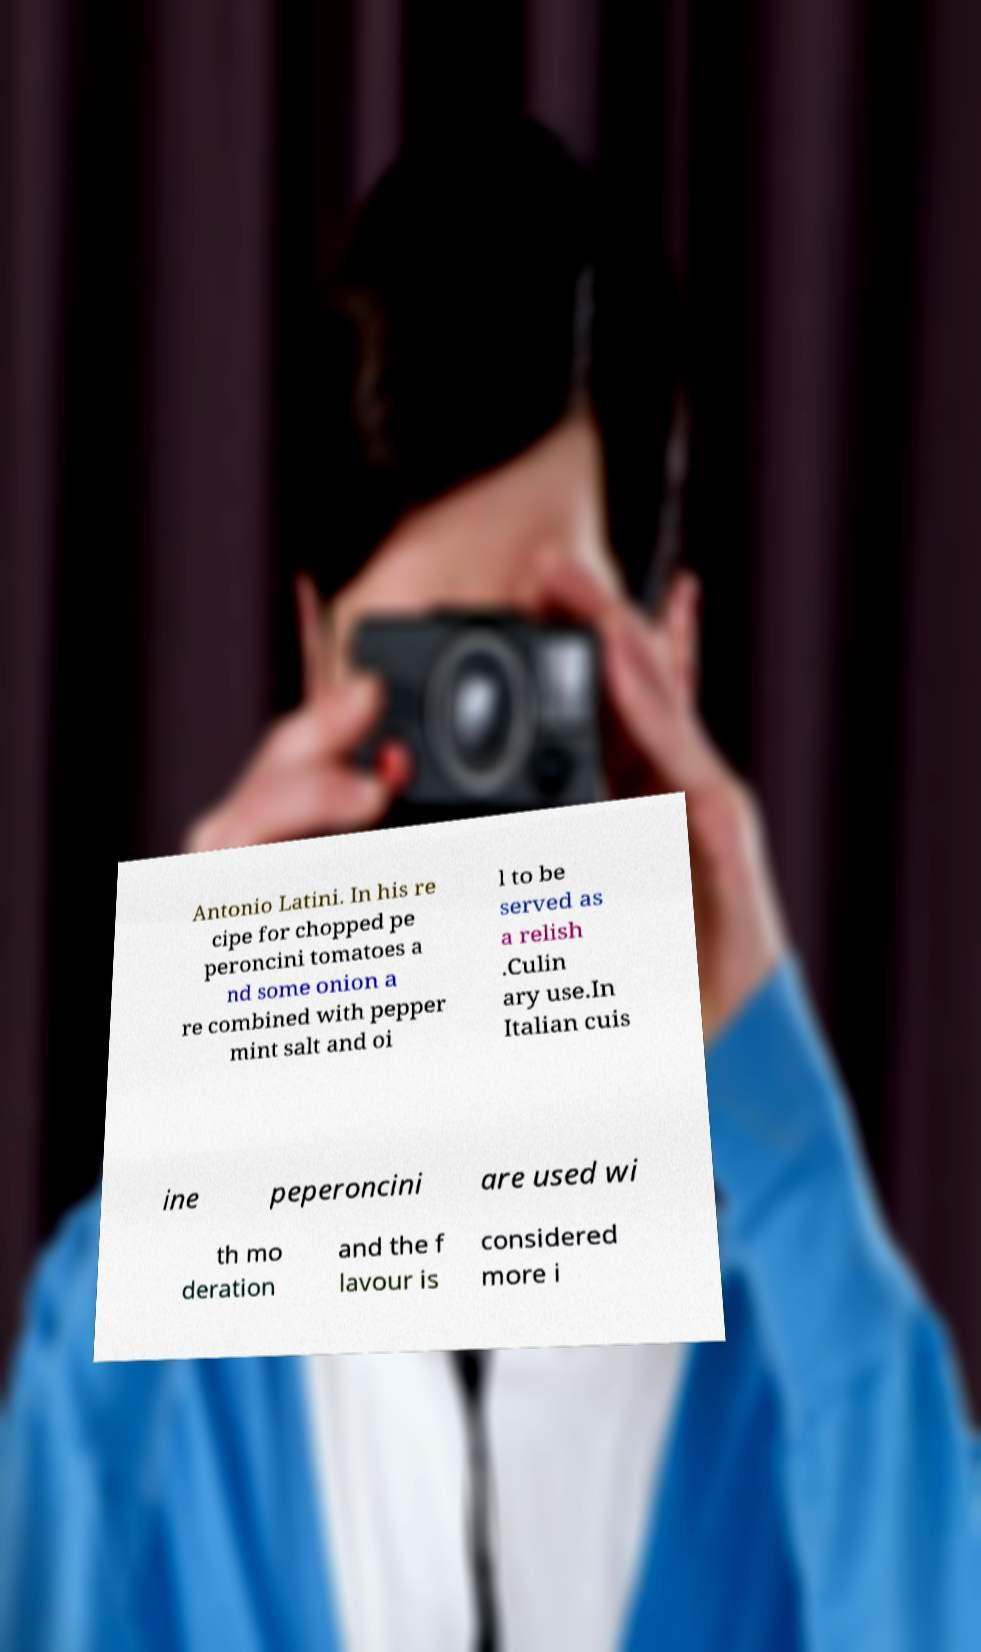Can you accurately transcribe the text from the provided image for me? Antonio Latini. In his re cipe for chopped pe peroncini tomatoes a nd some onion a re combined with pepper mint salt and oi l to be served as a relish .Culin ary use.In Italian cuis ine peperoncini are used wi th mo deration and the f lavour is considered more i 